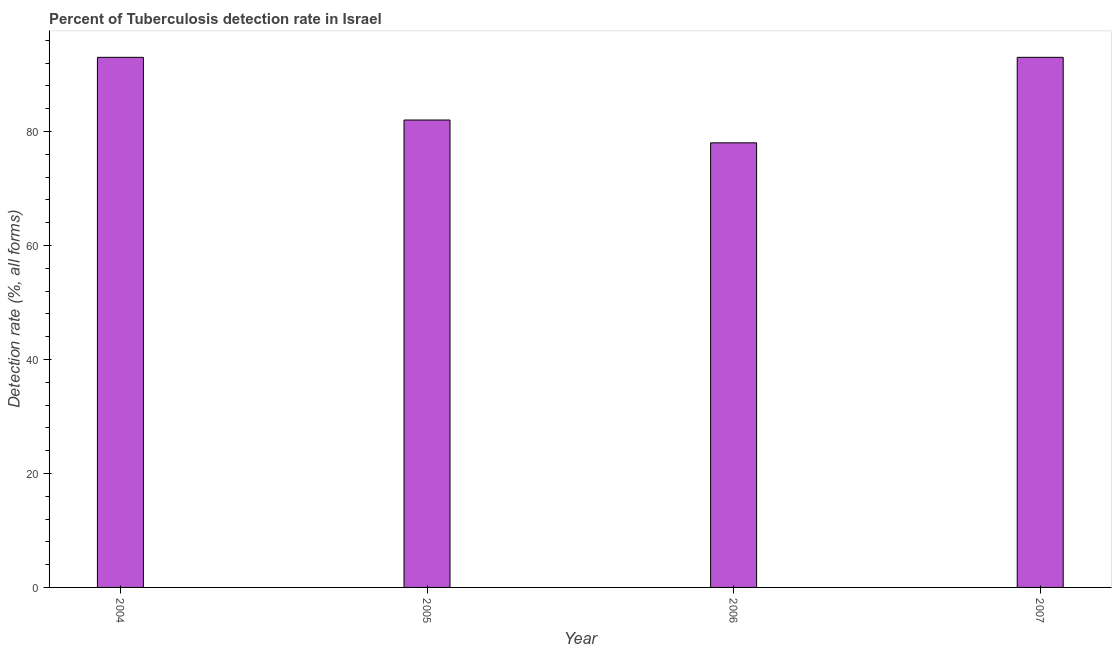What is the title of the graph?
Your response must be concise. Percent of Tuberculosis detection rate in Israel. What is the label or title of the X-axis?
Give a very brief answer. Year. What is the label or title of the Y-axis?
Ensure brevity in your answer.  Detection rate (%, all forms). What is the detection rate of tuberculosis in 2007?
Provide a short and direct response. 93. Across all years, what is the maximum detection rate of tuberculosis?
Provide a succinct answer. 93. In which year was the detection rate of tuberculosis maximum?
Provide a succinct answer. 2004. What is the sum of the detection rate of tuberculosis?
Offer a very short reply. 346. What is the difference between the detection rate of tuberculosis in 2005 and 2006?
Make the answer very short. 4. What is the average detection rate of tuberculosis per year?
Your answer should be very brief. 86. What is the median detection rate of tuberculosis?
Make the answer very short. 87.5. Do a majority of the years between 2007 and 2005 (inclusive) have detection rate of tuberculosis greater than 8 %?
Provide a succinct answer. Yes. What is the ratio of the detection rate of tuberculosis in 2006 to that in 2007?
Your response must be concise. 0.84. What is the difference between the highest and the second highest detection rate of tuberculosis?
Give a very brief answer. 0. What is the difference between the highest and the lowest detection rate of tuberculosis?
Make the answer very short. 15. In how many years, is the detection rate of tuberculosis greater than the average detection rate of tuberculosis taken over all years?
Offer a very short reply. 2. How many years are there in the graph?
Offer a terse response. 4. What is the difference between two consecutive major ticks on the Y-axis?
Provide a short and direct response. 20. Are the values on the major ticks of Y-axis written in scientific E-notation?
Your answer should be very brief. No. What is the Detection rate (%, all forms) of 2004?
Keep it short and to the point. 93. What is the Detection rate (%, all forms) in 2007?
Offer a terse response. 93. What is the difference between the Detection rate (%, all forms) in 2004 and 2007?
Your answer should be very brief. 0. What is the difference between the Detection rate (%, all forms) in 2005 and 2007?
Offer a very short reply. -11. What is the ratio of the Detection rate (%, all forms) in 2004 to that in 2005?
Your answer should be compact. 1.13. What is the ratio of the Detection rate (%, all forms) in 2004 to that in 2006?
Your response must be concise. 1.19. What is the ratio of the Detection rate (%, all forms) in 2005 to that in 2006?
Make the answer very short. 1.05. What is the ratio of the Detection rate (%, all forms) in 2005 to that in 2007?
Your response must be concise. 0.88. What is the ratio of the Detection rate (%, all forms) in 2006 to that in 2007?
Keep it short and to the point. 0.84. 